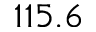<formula> <loc_0><loc_0><loc_500><loc_500>1 1 5 . 6</formula> 